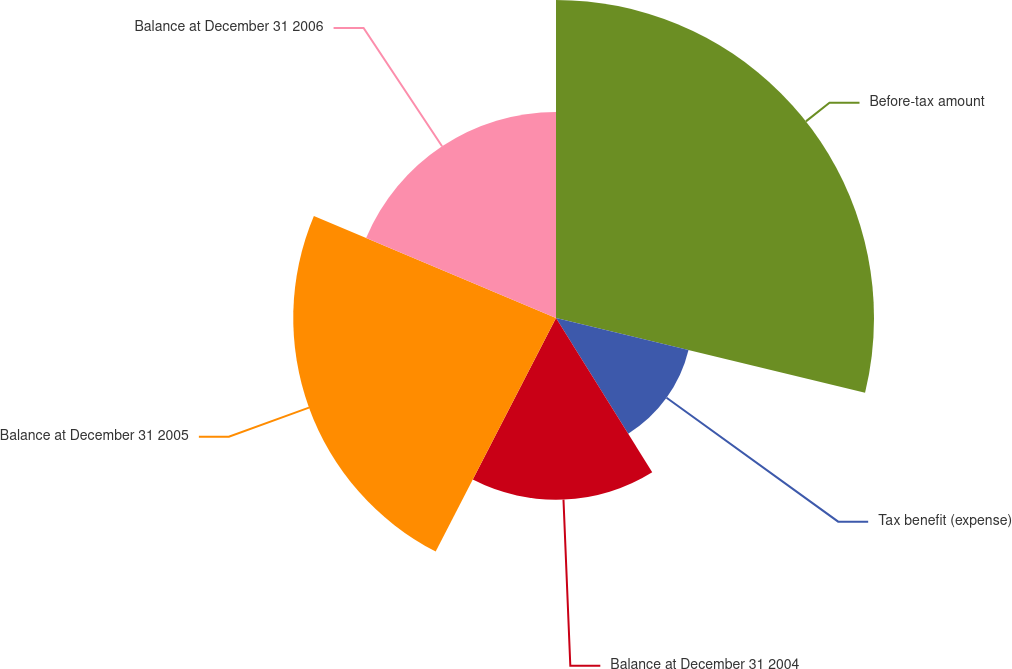<chart> <loc_0><loc_0><loc_500><loc_500><pie_chart><fcel>Before-tax amount<fcel>Tax benefit (expense)<fcel>Balance at December 31 2004<fcel>Balance at December 31 2005<fcel>Balance at December 31 2006<nl><fcel>28.78%<fcel>12.34%<fcel>16.45%<fcel>23.78%<fcel>18.65%<nl></chart> 